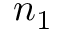<formula> <loc_0><loc_0><loc_500><loc_500>n _ { 1 }</formula> 